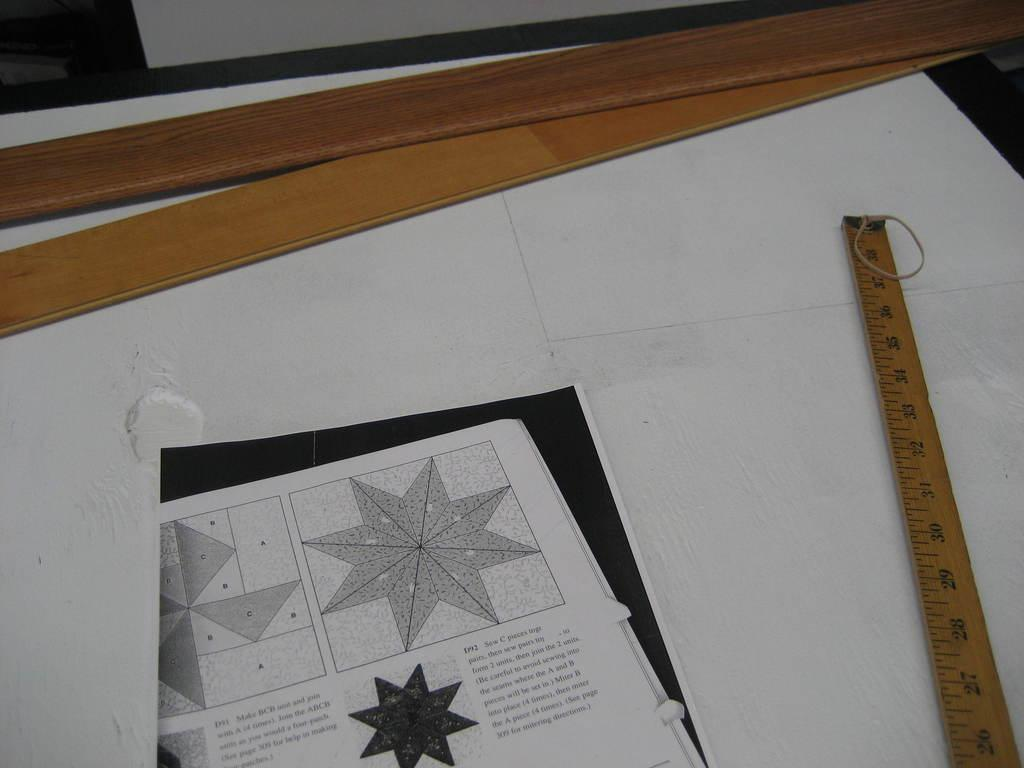<image>
Relay a brief, clear account of the picture shown. A yard stick is laid next to a quilt pattern with instructions such as "Be careful to avoid sewing into the seams..." 